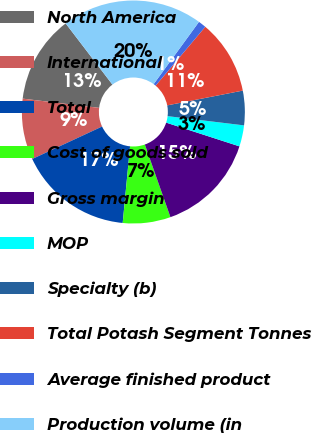Convert chart. <chart><loc_0><loc_0><loc_500><loc_500><pie_chart><fcel>North America<fcel>International<fcel>Total<fcel>Cost of goods sold<fcel>Gross margin<fcel>MOP<fcel>Specialty (b)<fcel>Total Potash Segment Tonnes<fcel>Average finished product<fcel>Production volume (in<nl><fcel>12.7%<fcel>8.84%<fcel>16.55%<fcel>6.92%<fcel>14.62%<fcel>3.07%<fcel>4.99%<fcel>10.77%<fcel>1.14%<fcel>20.4%<nl></chart> 